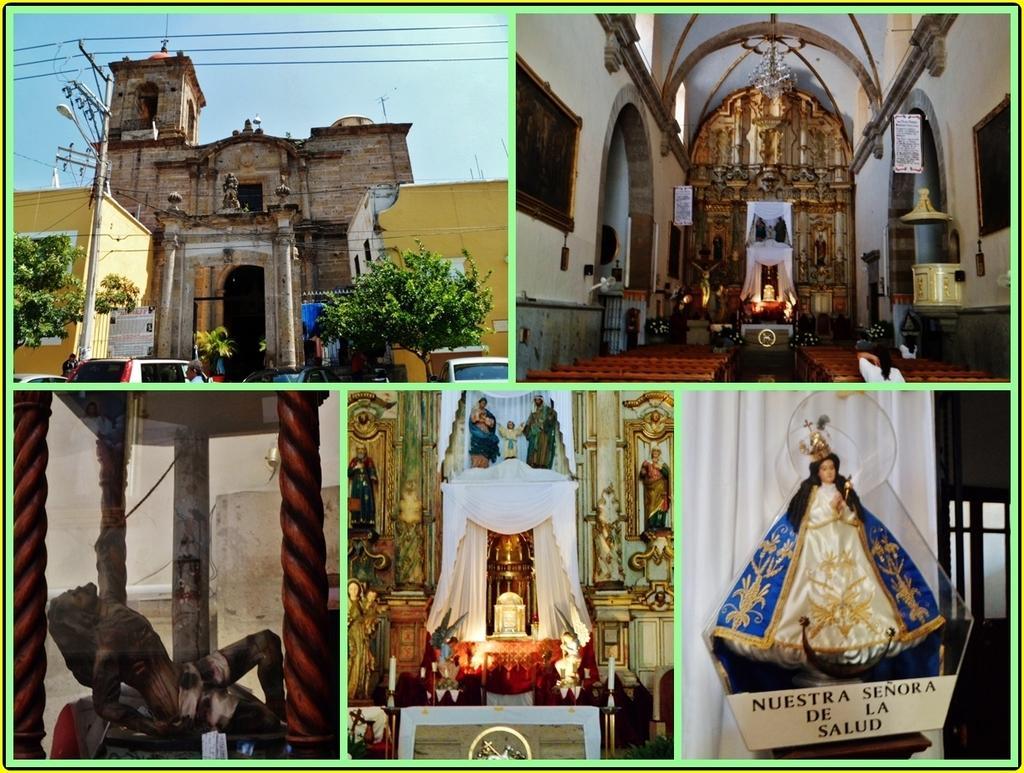Describe this image in one or two sentences. This is an edited image with the borders. at the top right corner we can see a chandelier, benches and some other objects. At the top left corner there is a sky, cables, buildings, street light, pole, vehicles and trees. At the bottom we can see the sculptures of persons and we can see that text on the image. In the background there is a white color curtain and and some other objects. 